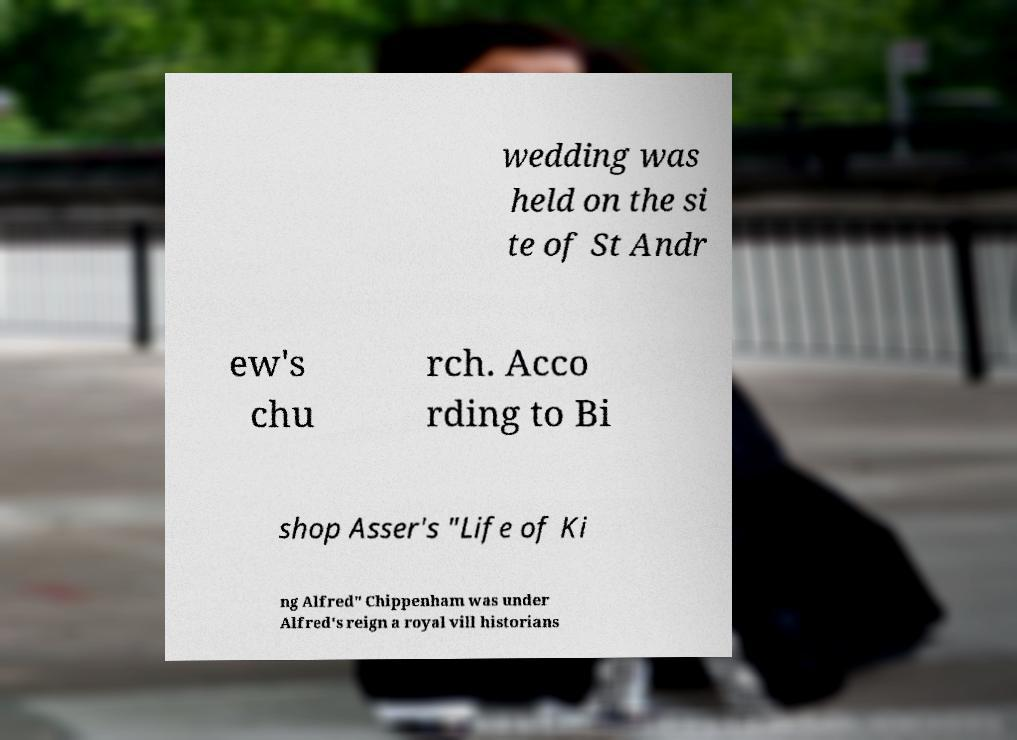What messages or text are displayed in this image? I need them in a readable, typed format. wedding was held on the si te of St Andr ew's chu rch. Acco rding to Bi shop Asser's "Life of Ki ng Alfred" Chippenham was under Alfred's reign a royal vill historians 